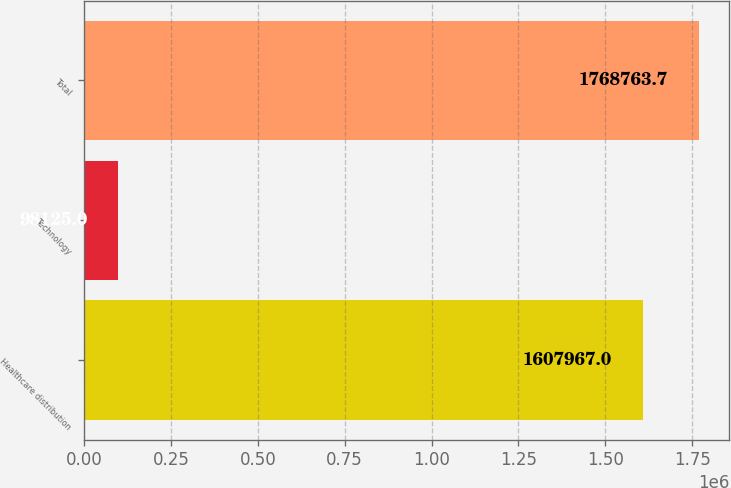Convert chart to OTSL. <chart><loc_0><loc_0><loc_500><loc_500><bar_chart><fcel>Healthcare distribution<fcel>Technology<fcel>Total<nl><fcel>1.60797e+06<fcel>98125<fcel>1.76876e+06<nl></chart> 